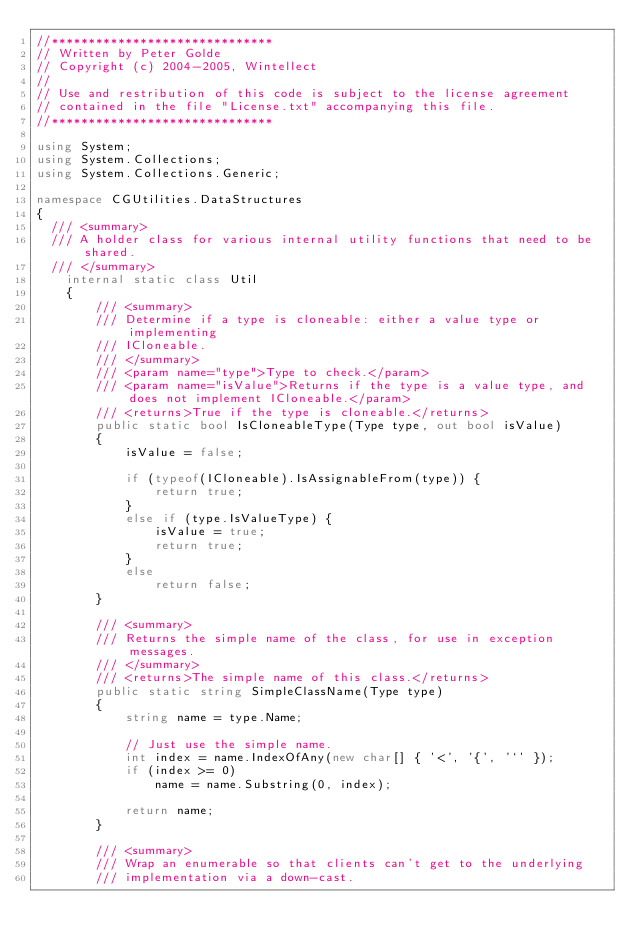Convert code to text. <code><loc_0><loc_0><loc_500><loc_500><_C#_>//******************************
// Written by Peter Golde
// Copyright (c) 2004-2005, Wintellect
//
// Use and restribution of this code is subject to the license agreement 
// contained in the file "License.txt" accompanying this file.
//******************************

using System;
using System.Collections;
using System.Collections.Generic;

namespace CGUtilities.DataStructures
{
	/// <summary>
	/// A holder class for various internal utility functions that need to be shared.
	/// </summary>
    internal static class Util
    {
        /// <summary>
        /// Determine if a type is cloneable: either a value type or implementing
        /// ICloneable.
        /// </summary>
        /// <param name="type">Type to check.</param>
        /// <param name="isValue">Returns if the type is a value type, and does not implement ICloneable.</param>
        /// <returns>True if the type is cloneable.</returns>
        public static bool IsCloneableType(Type type, out bool isValue)
        {
            isValue = false;

            if (typeof(ICloneable).IsAssignableFrom(type)) {
                return true;
            }
            else if (type.IsValueType) {
                isValue = true;
                return true;
            }
            else
                return false;
        }

        /// <summary>
        /// Returns the simple name of the class, for use in exception messages. 
        /// </summary>
        /// <returns>The simple name of this class.</returns>
        public static string SimpleClassName(Type type)
        {
            string name = type.Name;

            // Just use the simple name.
            int index = name.IndexOfAny(new char[] { '<', '{', '`' });
            if (index >= 0)
                name = name.Substring(0, index);

            return name;
        }

        /// <summary>
        /// Wrap an enumerable so that clients can't get to the underlying 
        /// implementation via a down-cast.</code> 